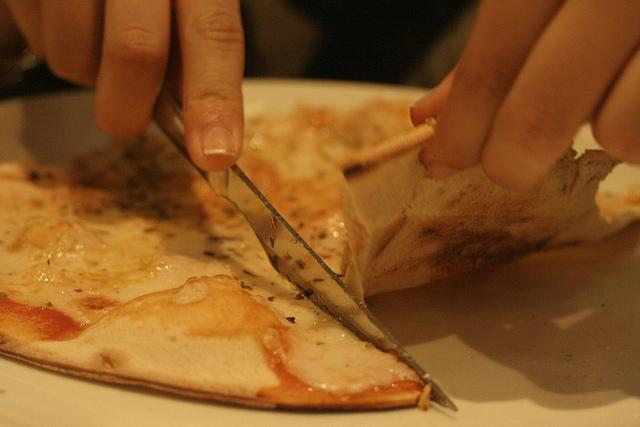What other utensil usually goes alongside the one shown? fork 